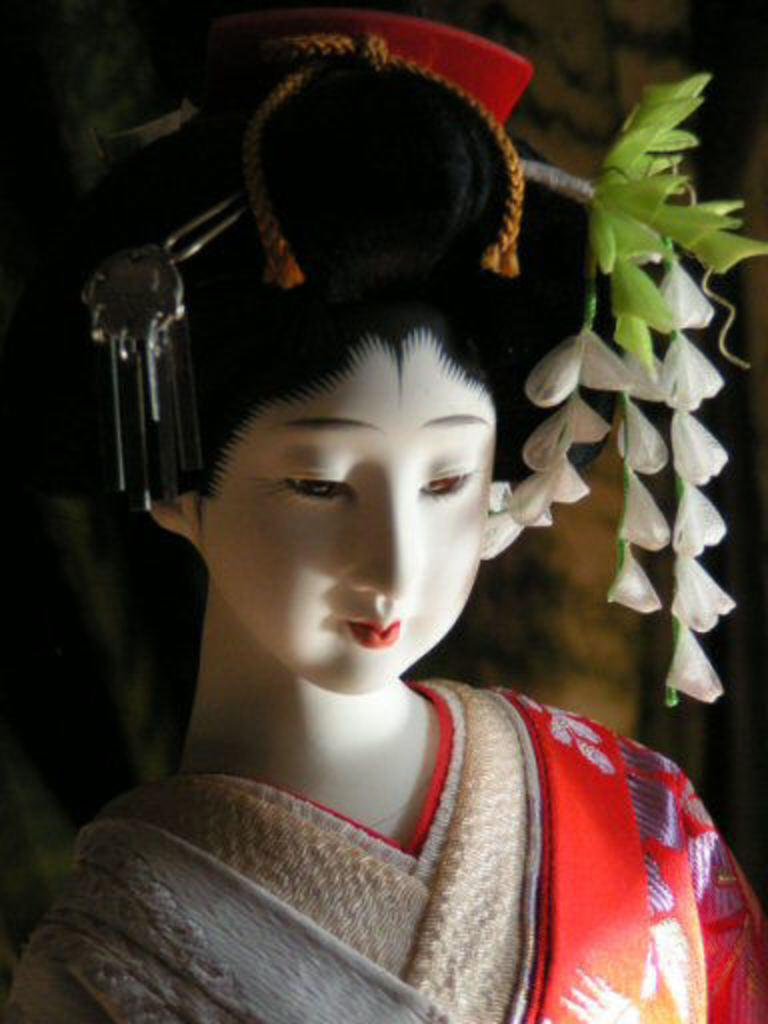What is the main subject in the center of the image? There is a doll in the center of the image. What other objects or elements can be seen in the image? There are flowers on the right side of the image. What type of lunch is being served in the office in the image? There is no mention of lunch or an office in the image; it features a doll and flowers. 